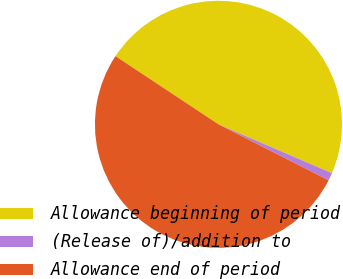Convert chart to OTSL. <chart><loc_0><loc_0><loc_500><loc_500><pie_chart><fcel>Allowance beginning of period<fcel>(Release of)/addition to<fcel>Allowance end of period<nl><fcel>47.16%<fcel>1.01%<fcel>51.83%<nl></chart> 